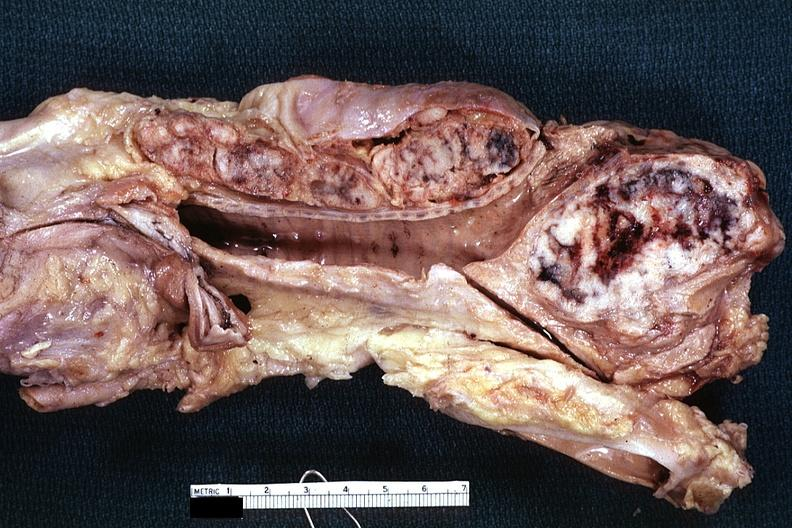what is present?
Answer the question using a single word or phrase. Metastatic carcinoma 